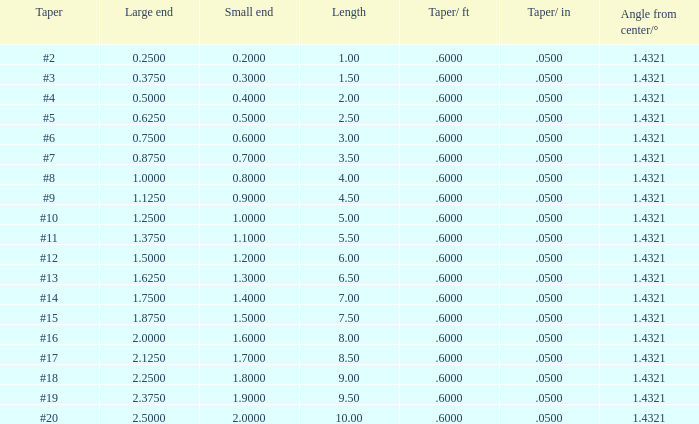375? None. 